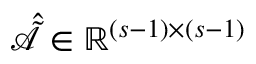Convert formula to latex. <formula><loc_0><loc_0><loc_500><loc_500>\hat { \tilde { \mathcal { A } } } \in \mathbb { R } ^ { ( s - 1 ) \times ( s - 1 ) }</formula> 